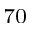<formula> <loc_0><loc_0><loc_500><loc_500>_ { 7 0 }</formula> 